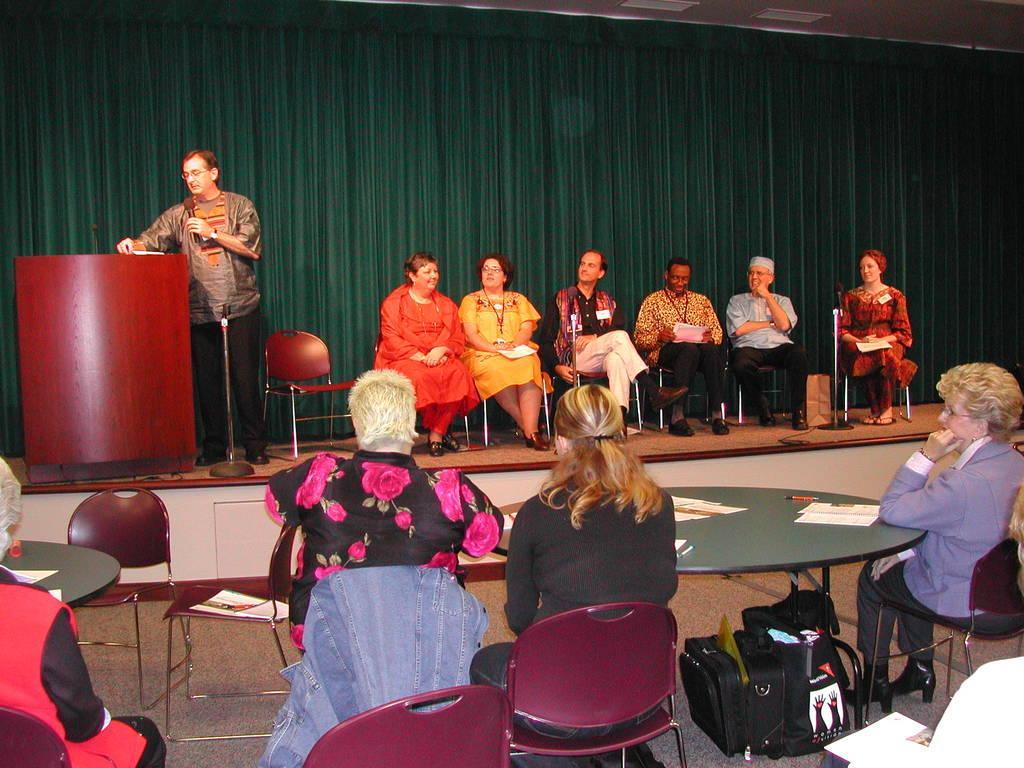Please provide a concise description of this image. In the foreground of the picture there are people, chairs, tables, papers, pen, bags and other objects. In the center of the picture there is a stage, on the stage there are women, men, chairs, podium, mic and other objects. In the background there is a green colored curtain. 